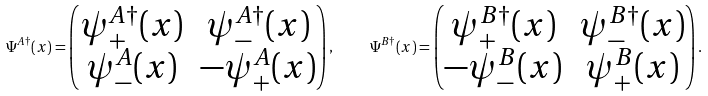<formula> <loc_0><loc_0><loc_500><loc_500>\Psi ^ { A \dagger } ( x ) = \begin{pmatrix} \psi ^ { A \dagger } _ { + } ( x ) & \psi ^ { A \dagger } _ { - } ( x ) \\ \psi ^ { A } _ { - } ( x ) & - \psi ^ { A } _ { + } ( x ) \end{pmatrix} , \quad \Psi ^ { B \dagger } ( x ) = \begin{pmatrix} \psi ^ { B \dagger } _ { + } ( x ) & \psi ^ { B \dagger } _ { - } ( x ) \\ - \psi ^ { B } _ { - } ( x ) & \psi ^ { B } _ { + } ( x ) \end{pmatrix} .</formula> 